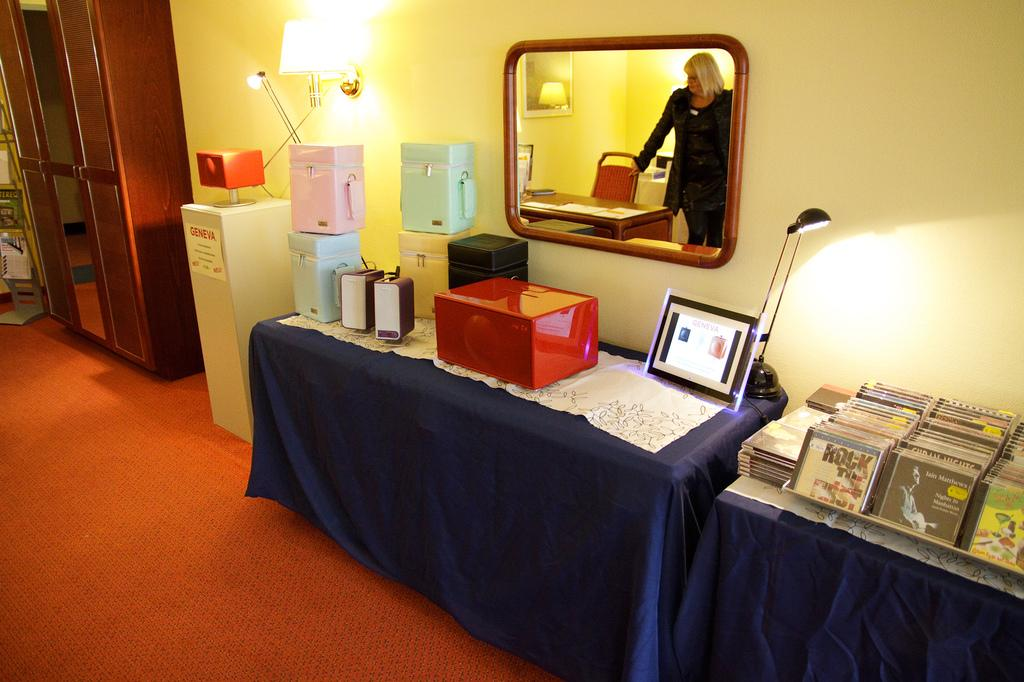<image>
Present a compact description of the photo's key features. a conference with a box and a sign on the box that says  Geneva 